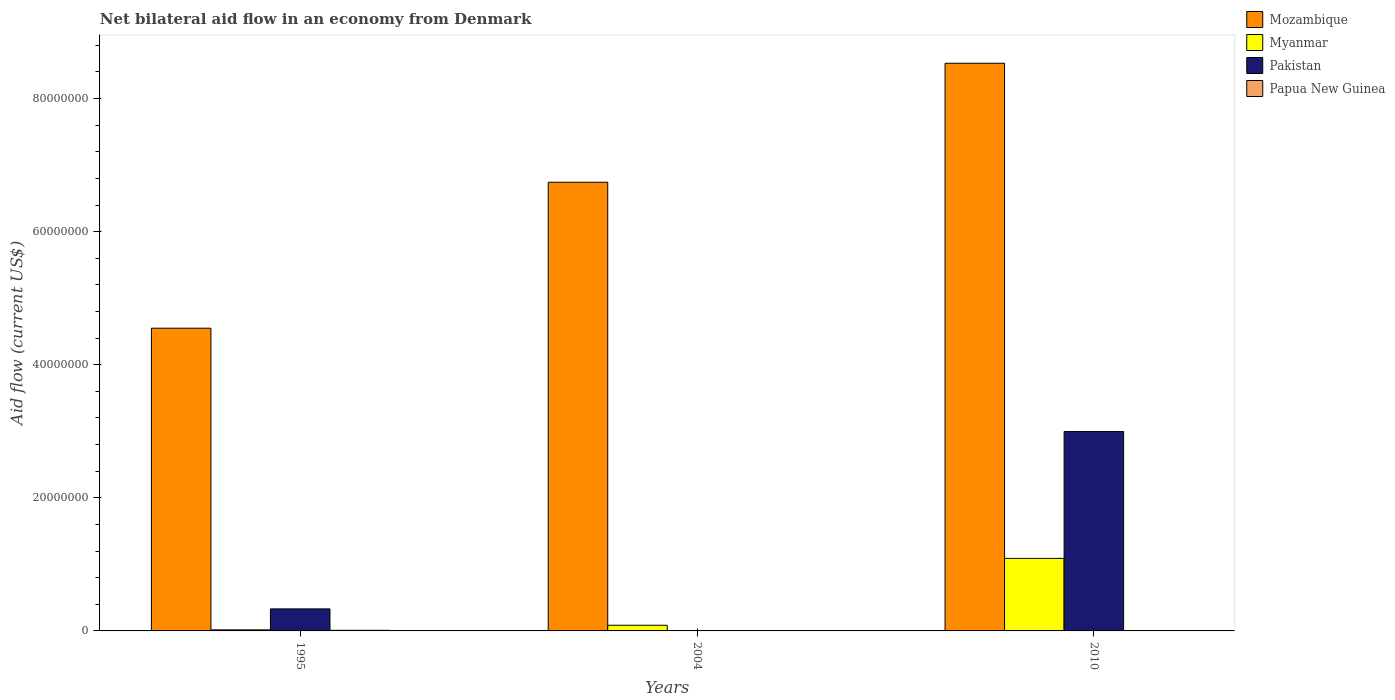How many groups of bars are there?
Provide a short and direct response. 3. Are the number of bars per tick equal to the number of legend labels?
Keep it short and to the point. No. What is the label of the 1st group of bars from the left?
Ensure brevity in your answer.  1995. In how many cases, is the number of bars for a given year not equal to the number of legend labels?
Provide a short and direct response. 1. What is the net bilateral aid flow in Mozambique in 1995?
Ensure brevity in your answer.  4.55e+07. Across all years, what is the maximum net bilateral aid flow in Papua New Guinea?
Provide a succinct answer. 9.00e+04. What is the total net bilateral aid flow in Mozambique in the graph?
Your response must be concise. 1.98e+08. What is the difference between the net bilateral aid flow in Mozambique in 1995 and that in 2010?
Give a very brief answer. -3.98e+07. What is the difference between the net bilateral aid flow in Mozambique in 2010 and the net bilateral aid flow in Myanmar in 2004?
Offer a very short reply. 8.44e+07. What is the average net bilateral aid flow in Pakistan per year?
Offer a very short reply. 1.11e+07. In the year 2010, what is the difference between the net bilateral aid flow in Papua New Guinea and net bilateral aid flow in Pakistan?
Ensure brevity in your answer.  -3.00e+07. What is the ratio of the net bilateral aid flow in Mozambique in 2004 to that in 2010?
Your answer should be compact. 0.79. What is the difference between the highest and the lowest net bilateral aid flow in Myanmar?
Offer a terse response. 1.07e+07. In how many years, is the net bilateral aid flow in Papua New Guinea greater than the average net bilateral aid flow in Papua New Guinea taken over all years?
Provide a succinct answer. 1. Are all the bars in the graph horizontal?
Provide a short and direct response. No. How many years are there in the graph?
Offer a very short reply. 3. Does the graph contain any zero values?
Ensure brevity in your answer.  Yes. Does the graph contain grids?
Make the answer very short. No. Where does the legend appear in the graph?
Your response must be concise. Top right. How many legend labels are there?
Your response must be concise. 4. How are the legend labels stacked?
Give a very brief answer. Vertical. What is the title of the graph?
Ensure brevity in your answer.  Net bilateral aid flow in an economy from Denmark. What is the Aid flow (current US$) in Mozambique in 1995?
Make the answer very short. 4.55e+07. What is the Aid flow (current US$) in Pakistan in 1995?
Your answer should be compact. 3.31e+06. What is the Aid flow (current US$) in Mozambique in 2004?
Provide a succinct answer. 6.74e+07. What is the Aid flow (current US$) of Myanmar in 2004?
Offer a very short reply. 8.50e+05. What is the Aid flow (current US$) of Mozambique in 2010?
Your answer should be very brief. 8.53e+07. What is the Aid flow (current US$) of Myanmar in 2010?
Your response must be concise. 1.09e+07. What is the Aid flow (current US$) of Pakistan in 2010?
Make the answer very short. 3.00e+07. What is the Aid flow (current US$) in Papua New Guinea in 2010?
Give a very brief answer. 10000. Across all years, what is the maximum Aid flow (current US$) of Mozambique?
Keep it short and to the point. 8.53e+07. Across all years, what is the maximum Aid flow (current US$) of Myanmar?
Offer a very short reply. 1.09e+07. Across all years, what is the maximum Aid flow (current US$) of Pakistan?
Make the answer very short. 3.00e+07. Across all years, what is the minimum Aid flow (current US$) of Mozambique?
Offer a very short reply. 4.55e+07. Across all years, what is the minimum Aid flow (current US$) in Myanmar?
Keep it short and to the point. 1.60e+05. Across all years, what is the minimum Aid flow (current US$) of Pakistan?
Offer a very short reply. 0. Across all years, what is the minimum Aid flow (current US$) of Papua New Guinea?
Offer a terse response. 10000. What is the total Aid flow (current US$) in Mozambique in the graph?
Your answer should be very brief. 1.98e+08. What is the total Aid flow (current US$) of Myanmar in the graph?
Offer a terse response. 1.19e+07. What is the total Aid flow (current US$) of Pakistan in the graph?
Make the answer very short. 3.33e+07. What is the difference between the Aid flow (current US$) of Mozambique in 1995 and that in 2004?
Provide a succinct answer. -2.19e+07. What is the difference between the Aid flow (current US$) in Myanmar in 1995 and that in 2004?
Ensure brevity in your answer.  -6.90e+05. What is the difference between the Aid flow (current US$) of Mozambique in 1995 and that in 2010?
Provide a succinct answer. -3.98e+07. What is the difference between the Aid flow (current US$) in Myanmar in 1995 and that in 2010?
Keep it short and to the point. -1.07e+07. What is the difference between the Aid flow (current US$) in Pakistan in 1995 and that in 2010?
Make the answer very short. -2.66e+07. What is the difference between the Aid flow (current US$) in Mozambique in 2004 and that in 2010?
Offer a terse response. -1.79e+07. What is the difference between the Aid flow (current US$) of Myanmar in 2004 and that in 2010?
Provide a succinct answer. -1.00e+07. What is the difference between the Aid flow (current US$) of Papua New Guinea in 2004 and that in 2010?
Your answer should be compact. 3.00e+04. What is the difference between the Aid flow (current US$) in Mozambique in 1995 and the Aid flow (current US$) in Myanmar in 2004?
Your answer should be very brief. 4.46e+07. What is the difference between the Aid flow (current US$) in Mozambique in 1995 and the Aid flow (current US$) in Papua New Guinea in 2004?
Provide a succinct answer. 4.54e+07. What is the difference between the Aid flow (current US$) of Myanmar in 1995 and the Aid flow (current US$) of Papua New Guinea in 2004?
Your answer should be compact. 1.20e+05. What is the difference between the Aid flow (current US$) in Pakistan in 1995 and the Aid flow (current US$) in Papua New Guinea in 2004?
Offer a very short reply. 3.27e+06. What is the difference between the Aid flow (current US$) in Mozambique in 1995 and the Aid flow (current US$) in Myanmar in 2010?
Give a very brief answer. 3.46e+07. What is the difference between the Aid flow (current US$) in Mozambique in 1995 and the Aid flow (current US$) in Pakistan in 2010?
Offer a terse response. 1.55e+07. What is the difference between the Aid flow (current US$) in Mozambique in 1995 and the Aid flow (current US$) in Papua New Guinea in 2010?
Ensure brevity in your answer.  4.55e+07. What is the difference between the Aid flow (current US$) in Myanmar in 1995 and the Aid flow (current US$) in Pakistan in 2010?
Provide a succinct answer. -2.98e+07. What is the difference between the Aid flow (current US$) in Pakistan in 1995 and the Aid flow (current US$) in Papua New Guinea in 2010?
Give a very brief answer. 3.30e+06. What is the difference between the Aid flow (current US$) in Mozambique in 2004 and the Aid flow (current US$) in Myanmar in 2010?
Keep it short and to the point. 5.65e+07. What is the difference between the Aid flow (current US$) of Mozambique in 2004 and the Aid flow (current US$) of Pakistan in 2010?
Your response must be concise. 3.75e+07. What is the difference between the Aid flow (current US$) of Mozambique in 2004 and the Aid flow (current US$) of Papua New Guinea in 2010?
Your answer should be compact. 6.74e+07. What is the difference between the Aid flow (current US$) in Myanmar in 2004 and the Aid flow (current US$) in Pakistan in 2010?
Your response must be concise. -2.91e+07. What is the difference between the Aid flow (current US$) in Myanmar in 2004 and the Aid flow (current US$) in Papua New Guinea in 2010?
Your answer should be compact. 8.40e+05. What is the average Aid flow (current US$) in Mozambique per year?
Provide a succinct answer. 6.61e+07. What is the average Aid flow (current US$) of Myanmar per year?
Provide a succinct answer. 3.97e+06. What is the average Aid flow (current US$) of Pakistan per year?
Ensure brevity in your answer.  1.11e+07. What is the average Aid flow (current US$) in Papua New Guinea per year?
Provide a succinct answer. 4.67e+04. In the year 1995, what is the difference between the Aid flow (current US$) in Mozambique and Aid flow (current US$) in Myanmar?
Offer a very short reply. 4.53e+07. In the year 1995, what is the difference between the Aid flow (current US$) in Mozambique and Aid flow (current US$) in Pakistan?
Make the answer very short. 4.22e+07. In the year 1995, what is the difference between the Aid flow (current US$) of Mozambique and Aid flow (current US$) of Papua New Guinea?
Your answer should be compact. 4.54e+07. In the year 1995, what is the difference between the Aid flow (current US$) of Myanmar and Aid flow (current US$) of Pakistan?
Provide a short and direct response. -3.15e+06. In the year 1995, what is the difference between the Aid flow (current US$) of Pakistan and Aid flow (current US$) of Papua New Guinea?
Give a very brief answer. 3.22e+06. In the year 2004, what is the difference between the Aid flow (current US$) of Mozambique and Aid flow (current US$) of Myanmar?
Give a very brief answer. 6.66e+07. In the year 2004, what is the difference between the Aid flow (current US$) of Mozambique and Aid flow (current US$) of Papua New Guinea?
Your answer should be compact. 6.74e+07. In the year 2004, what is the difference between the Aid flow (current US$) of Myanmar and Aid flow (current US$) of Papua New Guinea?
Provide a short and direct response. 8.10e+05. In the year 2010, what is the difference between the Aid flow (current US$) in Mozambique and Aid flow (current US$) in Myanmar?
Your response must be concise. 7.44e+07. In the year 2010, what is the difference between the Aid flow (current US$) in Mozambique and Aid flow (current US$) in Pakistan?
Make the answer very short. 5.53e+07. In the year 2010, what is the difference between the Aid flow (current US$) of Mozambique and Aid flow (current US$) of Papua New Guinea?
Give a very brief answer. 8.53e+07. In the year 2010, what is the difference between the Aid flow (current US$) in Myanmar and Aid flow (current US$) in Pakistan?
Your response must be concise. -1.91e+07. In the year 2010, what is the difference between the Aid flow (current US$) of Myanmar and Aid flow (current US$) of Papua New Guinea?
Ensure brevity in your answer.  1.09e+07. In the year 2010, what is the difference between the Aid flow (current US$) in Pakistan and Aid flow (current US$) in Papua New Guinea?
Your answer should be very brief. 3.00e+07. What is the ratio of the Aid flow (current US$) of Mozambique in 1995 to that in 2004?
Your answer should be very brief. 0.67. What is the ratio of the Aid flow (current US$) of Myanmar in 1995 to that in 2004?
Keep it short and to the point. 0.19. What is the ratio of the Aid flow (current US$) in Papua New Guinea in 1995 to that in 2004?
Your response must be concise. 2.25. What is the ratio of the Aid flow (current US$) of Mozambique in 1995 to that in 2010?
Offer a very short reply. 0.53. What is the ratio of the Aid flow (current US$) in Myanmar in 1995 to that in 2010?
Your answer should be compact. 0.01. What is the ratio of the Aid flow (current US$) of Pakistan in 1995 to that in 2010?
Keep it short and to the point. 0.11. What is the ratio of the Aid flow (current US$) of Papua New Guinea in 1995 to that in 2010?
Your answer should be very brief. 9. What is the ratio of the Aid flow (current US$) of Mozambique in 2004 to that in 2010?
Offer a very short reply. 0.79. What is the ratio of the Aid flow (current US$) of Myanmar in 2004 to that in 2010?
Keep it short and to the point. 0.08. What is the ratio of the Aid flow (current US$) in Papua New Guinea in 2004 to that in 2010?
Offer a very short reply. 4. What is the difference between the highest and the second highest Aid flow (current US$) in Mozambique?
Offer a very short reply. 1.79e+07. What is the difference between the highest and the second highest Aid flow (current US$) of Myanmar?
Your answer should be compact. 1.00e+07. What is the difference between the highest and the lowest Aid flow (current US$) of Mozambique?
Your answer should be very brief. 3.98e+07. What is the difference between the highest and the lowest Aid flow (current US$) of Myanmar?
Your answer should be very brief. 1.07e+07. What is the difference between the highest and the lowest Aid flow (current US$) of Pakistan?
Keep it short and to the point. 3.00e+07. 